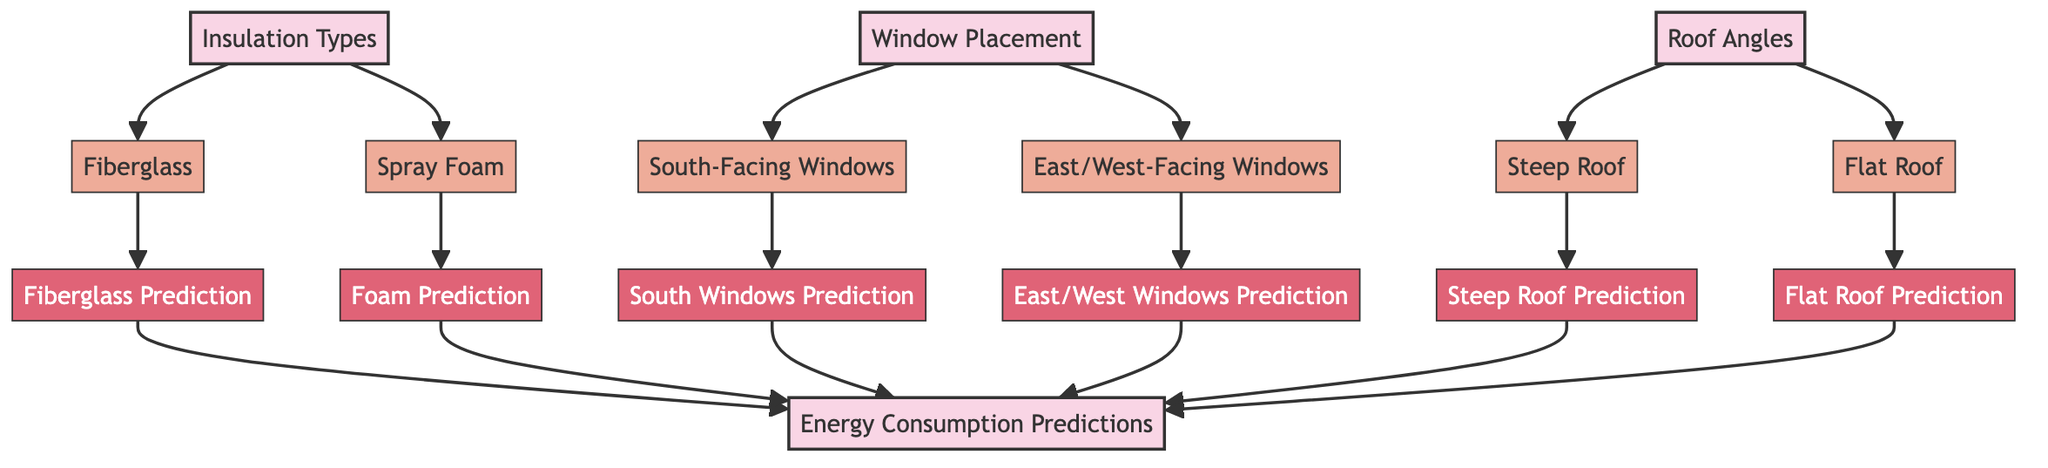What are the insulation types shown in the diagram? The diagram includes two types of insulation: Fiberglass and Spray Foam. These are the only two sub-nodes connected to the Insulation Types node.
Answer: Fiberglass, Spray Foam How many predictions are listed for window placements? The diagram shows two predictions associated with window placements: one for South-Facing Windows and another for East/West-Facing Windows. There are no other predictions for window placements.
Answer: 2 Which roof angle has a prediction labeled as "Steep Roof Prediction"? The diagram categorizes roof angles and assigns a prediction specifically labeled as "Steep Roof Prediction" under the Steep Roof sub-node. This is directly connected to the Roof Angles node.
Answer: Steep Roof Prediction What influences energy consumption predictions from insulation types? According to the diagram, energy consumption predictions from insulation types are influenced by Fiberglass and Spray Foam, leading to their respective predictions. The relationships are one direction from each of these sub-nodes to their predictions.
Answer: Fiberglass, Spray Foam Which sub-node leads to the "Energy Consumption Predictions"? The "Energy Consumption Predictions" is influenced by predictions derived from all the sub-nodes related to insulation, window placements, and roof angles. Thus, it connects to Fiberglass Prediction, Foam Prediction, South Windows Prediction, East/West Windows Prediction, Steep Roof Prediction, and Flat Roof Prediction.
Answer: All sub-nodes What shape represents the main topics in the diagram? In the diagram, main topics like Insulation Types, Window Placement, Roof Angles, and Energy Consumption Predictions are represented in rectangular shapes. This is further distinguishable by their color coding.
Answer: Rectangles Which type of window placement contributes to the least energy consumption? The diagram provides no explicit comparison of energy efficiency among the window types; however, it can imply that predictions derive from their respective categories (South-Facing and East/West). Therefore, further research beyond the diagram is required to validate which window placement is most efficient.
Answer: Not directly indicated How does the diagram categorize the main topics? The main topics are categorized by defining insulation types, window placements, and roof angles that impact the energy consumption of residential buildings. This is visually represented by a categorization of nodes connected to energy consumption predictions.
Answer: By topic categories 